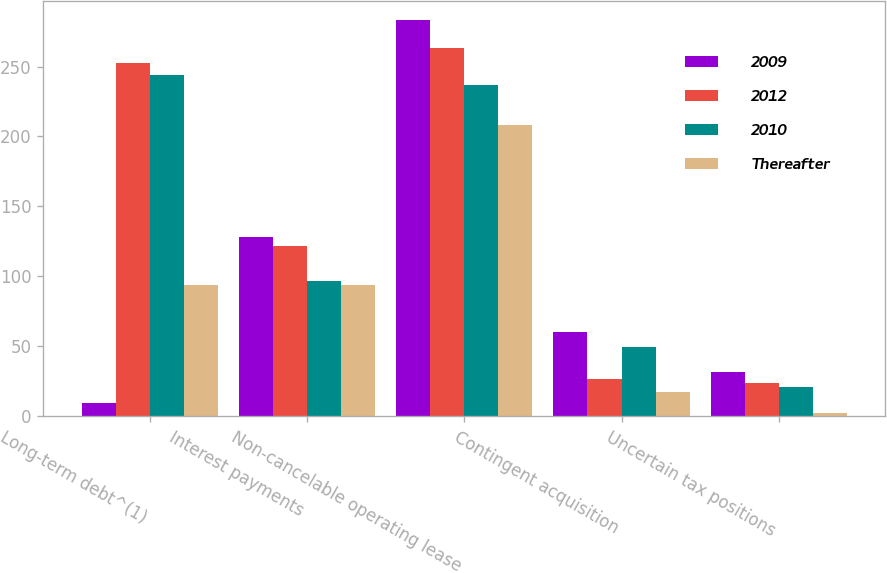Convert chart to OTSL. <chart><loc_0><loc_0><loc_500><loc_500><stacked_bar_chart><ecel><fcel>Long-term debt^(1)<fcel>Interest payments<fcel>Non-cancelable operating lease<fcel>Contingent acquisition<fcel>Uncertain tax positions<nl><fcel>2009<fcel>9.2<fcel>128<fcel>283<fcel>60.4<fcel>31.5<nl><fcel>2012<fcel>252.3<fcel>122<fcel>263.4<fcel>26.4<fcel>24.1<nl><fcel>2010<fcel>244.1<fcel>96.8<fcel>236.7<fcel>49.8<fcel>21.1<nl><fcel>Thereafter<fcel>93.6<fcel>93.6<fcel>208<fcel>17.1<fcel>2.1<nl></chart> 